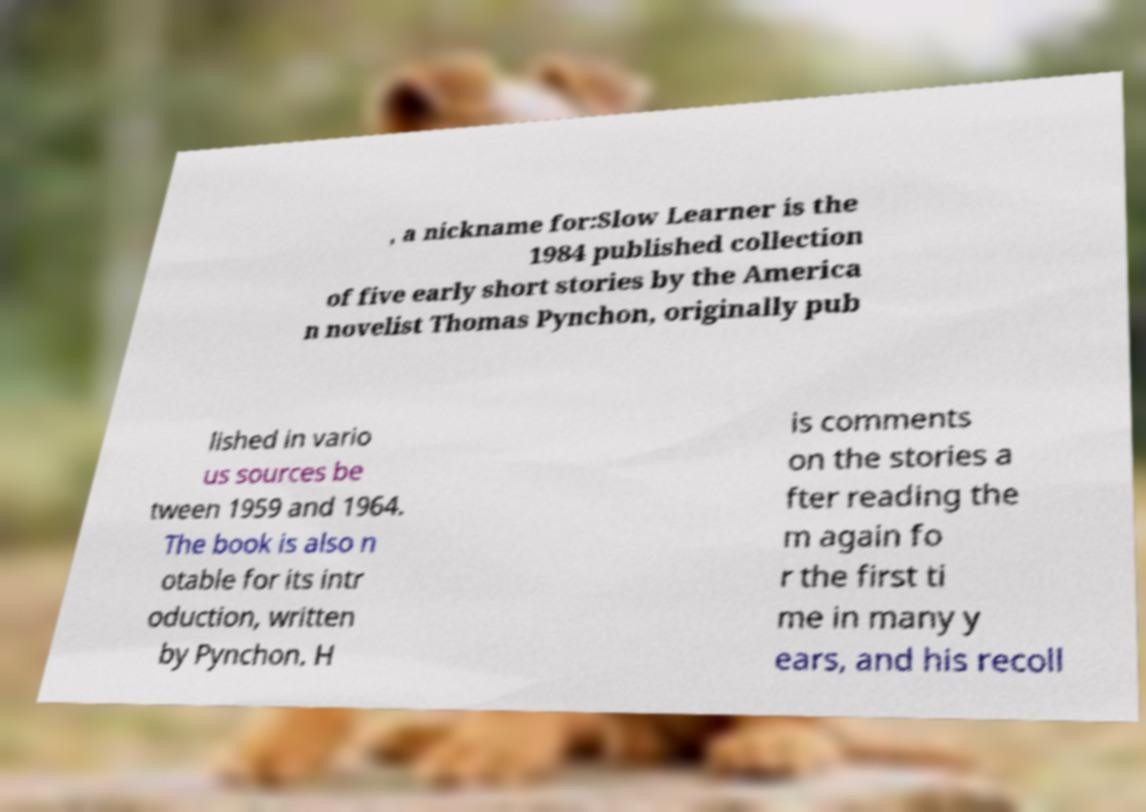There's text embedded in this image that I need extracted. Can you transcribe it verbatim? , a nickname for:Slow Learner is the 1984 published collection of five early short stories by the America n novelist Thomas Pynchon, originally pub lished in vario us sources be tween 1959 and 1964. The book is also n otable for its intr oduction, written by Pynchon. H is comments on the stories a fter reading the m again fo r the first ti me in many y ears, and his recoll 